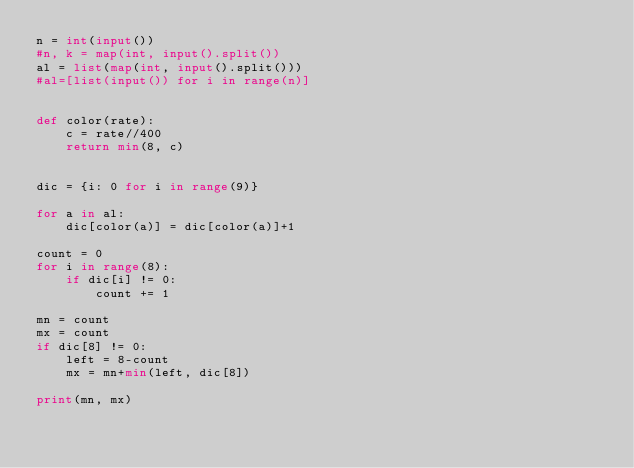Convert code to text. <code><loc_0><loc_0><loc_500><loc_500><_Python_>n = int(input())
#n, k = map(int, input().split())
al = list(map(int, input().split()))
#al=[list(input()) for i in range(n)]


def color(rate):
    c = rate//400
    return min(8, c)


dic = {i: 0 for i in range(9)}

for a in al:
    dic[color(a)] = dic[color(a)]+1

count = 0
for i in range(8):
    if dic[i] != 0:
        count += 1

mn = count
mx = count
if dic[8] != 0:
    left = 8-count
    mx = mn+min(left, dic[8])

print(mn, mx)
</code> 